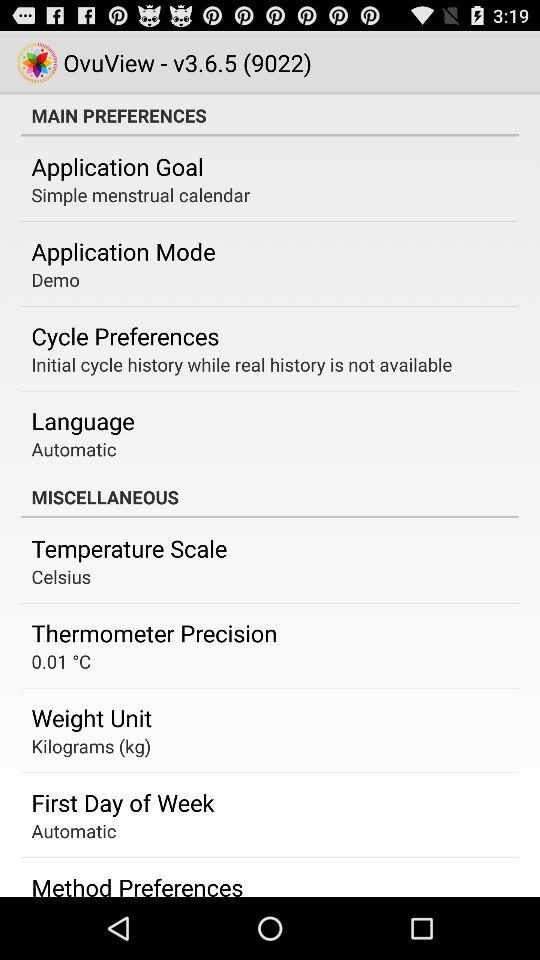What is the temperature of the "Thermometer Precision"? The temperature is 0.01 °C. 